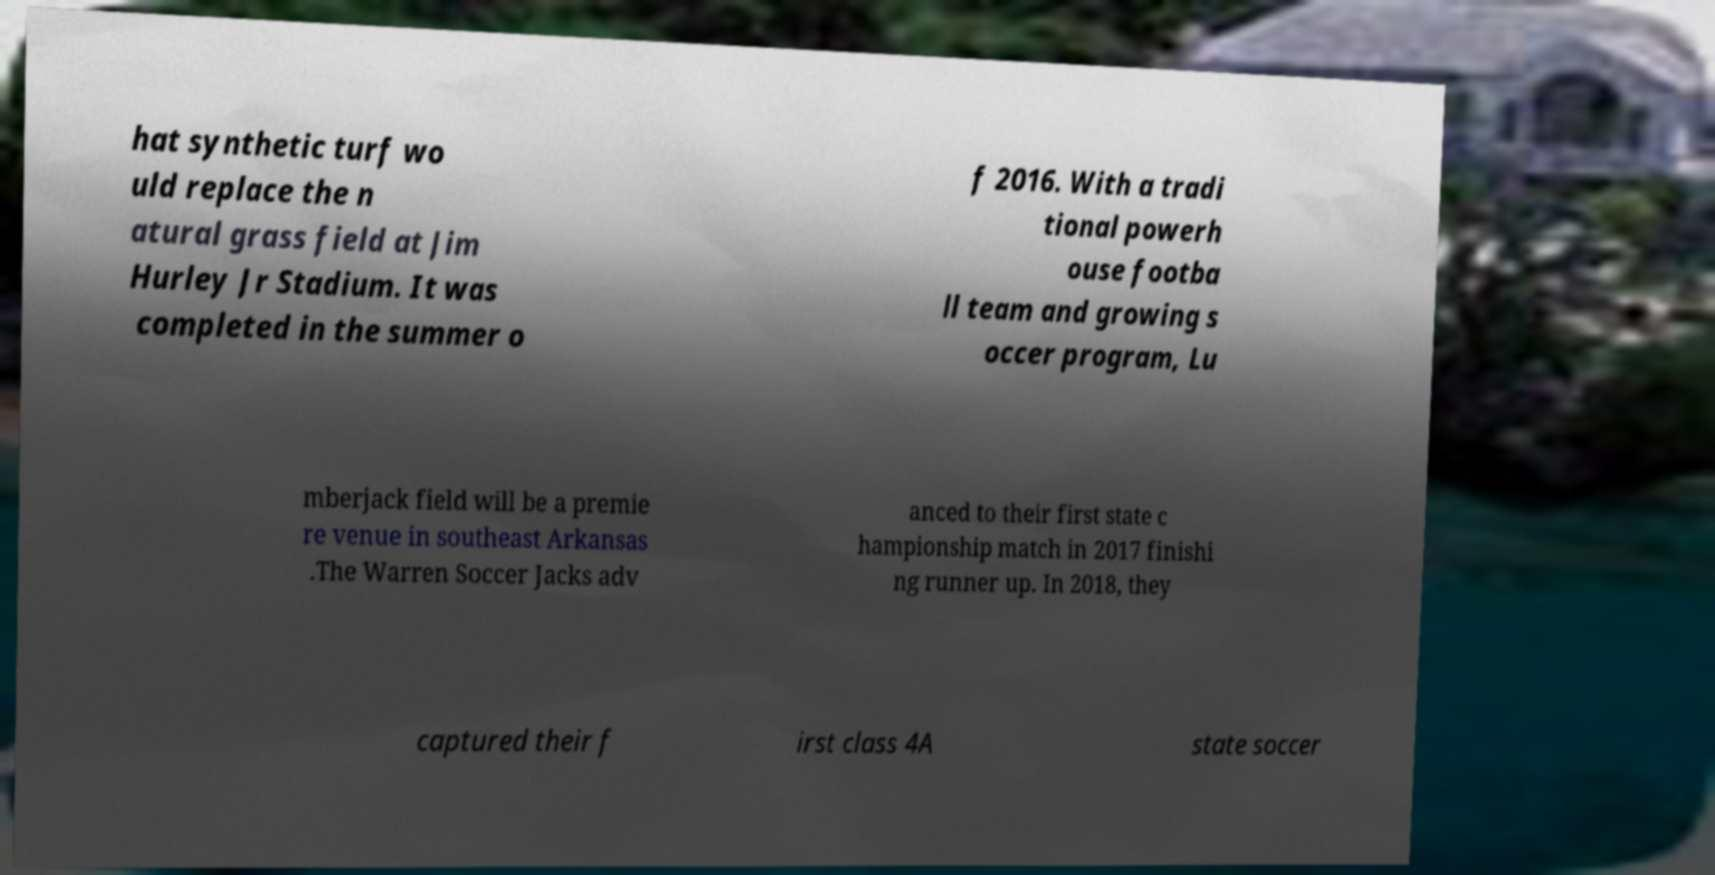Could you assist in decoding the text presented in this image and type it out clearly? hat synthetic turf wo uld replace the n atural grass field at Jim Hurley Jr Stadium. It was completed in the summer o f 2016. With a tradi tional powerh ouse footba ll team and growing s occer program, Lu mberjack field will be a premie re venue in southeast Arkansas .The Warren Soccer Jacks adv anced to their first state c hampionship match in 2017 finishi ng runner up. In 2018, they captured their f irst class 4A state soccer 